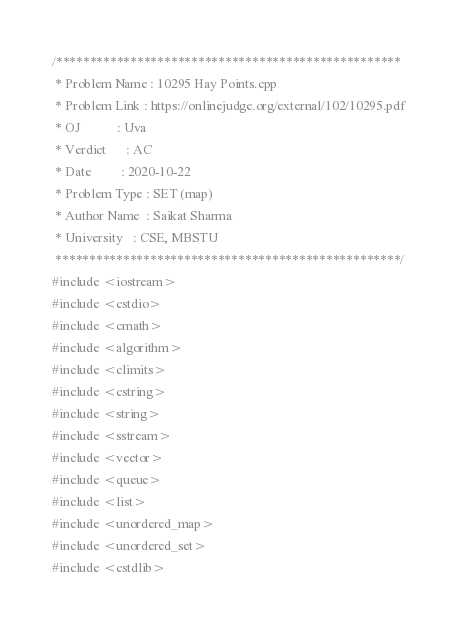Convert code to text. <code><loc_0><loc_0><loc_500><loc_500><_C++_>/***************************************************
 * Problem Name : 10295 Hay Points.cpp
 * Problem Link : https://onlinejudge.org/external/102/10295.pdf
 * OJ           : Uva
 * Verdict      : AC
 * Date         : 2020-10-22
 * Problem Type : SET (map)
 * Author Name  : Saikat Sharma
 * University   : CSE, MBSTU
 ***************************************************/
#include <iostream>
#include <cstdio>
#include <cmath>
#include <algorithm>
#include <climits>
#include <cstring>
#include <string>
#include <sstream>
#include <vector>
#include <queue>
#include <list>
#include <unordered_map>
#include <unordered_set>
#include <cstdlib></code> 